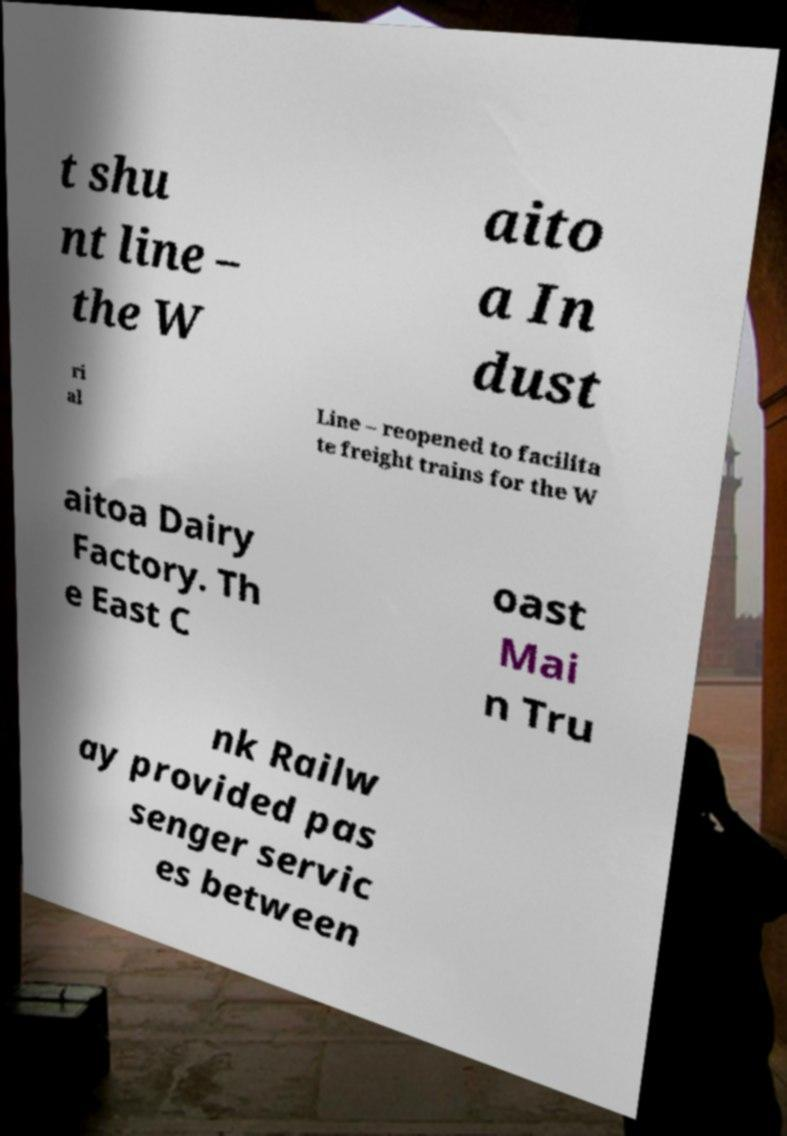Please read and relay the text visible in this image. What does it say? t shu nt line – the W aito a In dust ri al Line – reopened to facilita te freight trains for the W aitoa Dairy Factory. Th e East C oast Mai n Tru nk Railw ay provided pas senger servic es between 